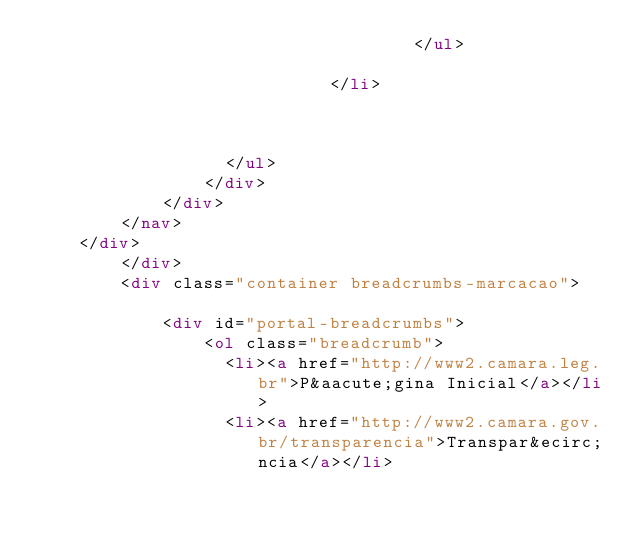Convert code to text. <code><loc_0><loc_0><loc_500><loc_500><_HTML_>                                    </ul>
                                
                            </li>
                        
                    
    
                  </ul>
                </div>
            </div>
        </nav>
    </div>
        </div>
		<div class="container breadcrumbs-marcacao">	
			<div id="portal-breadcrumbs">
				<ol class="breadcrumb">
				  <li><a href="http://www2.camara.leg.br">P&aacute;gina Inicial</a></li>
				  <li><a href="http://www2.camara.gov.br/transparencia">Transpar&ecirc;ncia</a></li></code> 